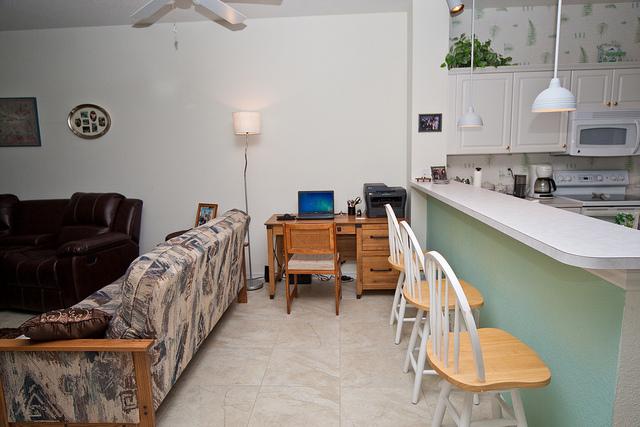What is on top of the desk near the laptop computer?
Short answer required. Printer. Is there a ceiling fan?
Short answer required. Yes. Where is the lamp?
Short answer required. Next to desk. Does the decor in this room match?
Give a very brief answer. No. 